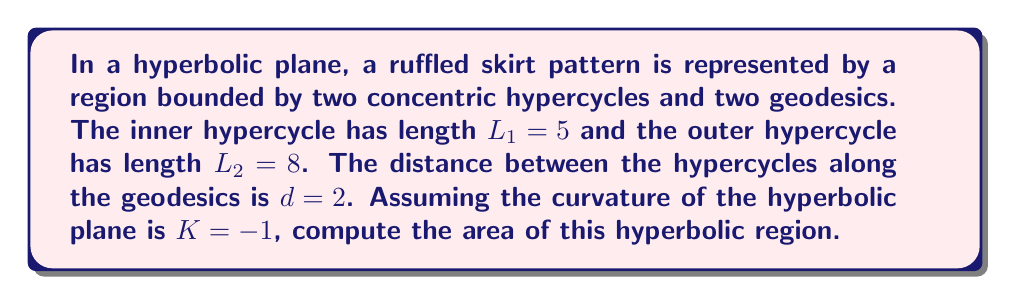Help me with this question. To calculate the area of this hyperbolic region, we'll follow these steps:

1) In hyperbolic geometry, the area of a region bounded by two concentric hypercycles and two geodesics is given by the formula:

   $$A = d(L_2 - L_1)$$

   where $d$ is the distance between the hypercycles, $L_2$ is the length of the outer hypercycle, and $L_1$ is the length of the inner hypercycle.

2) We are given:
   $d = 2$
   $L_2 = 8$
   $L_1 = 5$

3) Substituting these values into the formula:

   $$A = 2(8 - 5)$$

4) Simplifying:

   $$A = 2(3) = 6$$

5) Therefore, the area of the hyperbolic region is 6 square units.

Note: This formula assumes a curvature of $K = -1$, which is given in the problem statement. If the curvature were different, we would need to adjust the formula accordingly.
Answer: 6 square units 